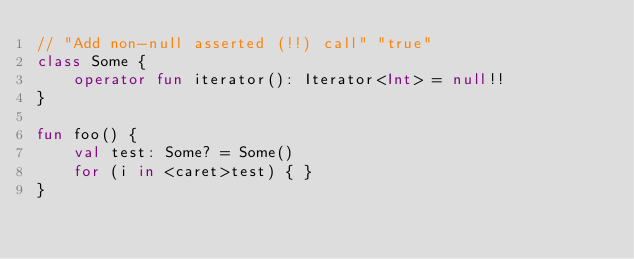Convert code to text. <code><loc_0><loc_0><loc_500><loc_500><_Kotlin_>// "Add non-null asserted (!!) call" "true"
class Some {
    operator fun iterator(): Iterator<Int> = null!!
}

fun foo() {
    val test: Some? = Some()
    for (i in <caret>test) { }
}
</code> 